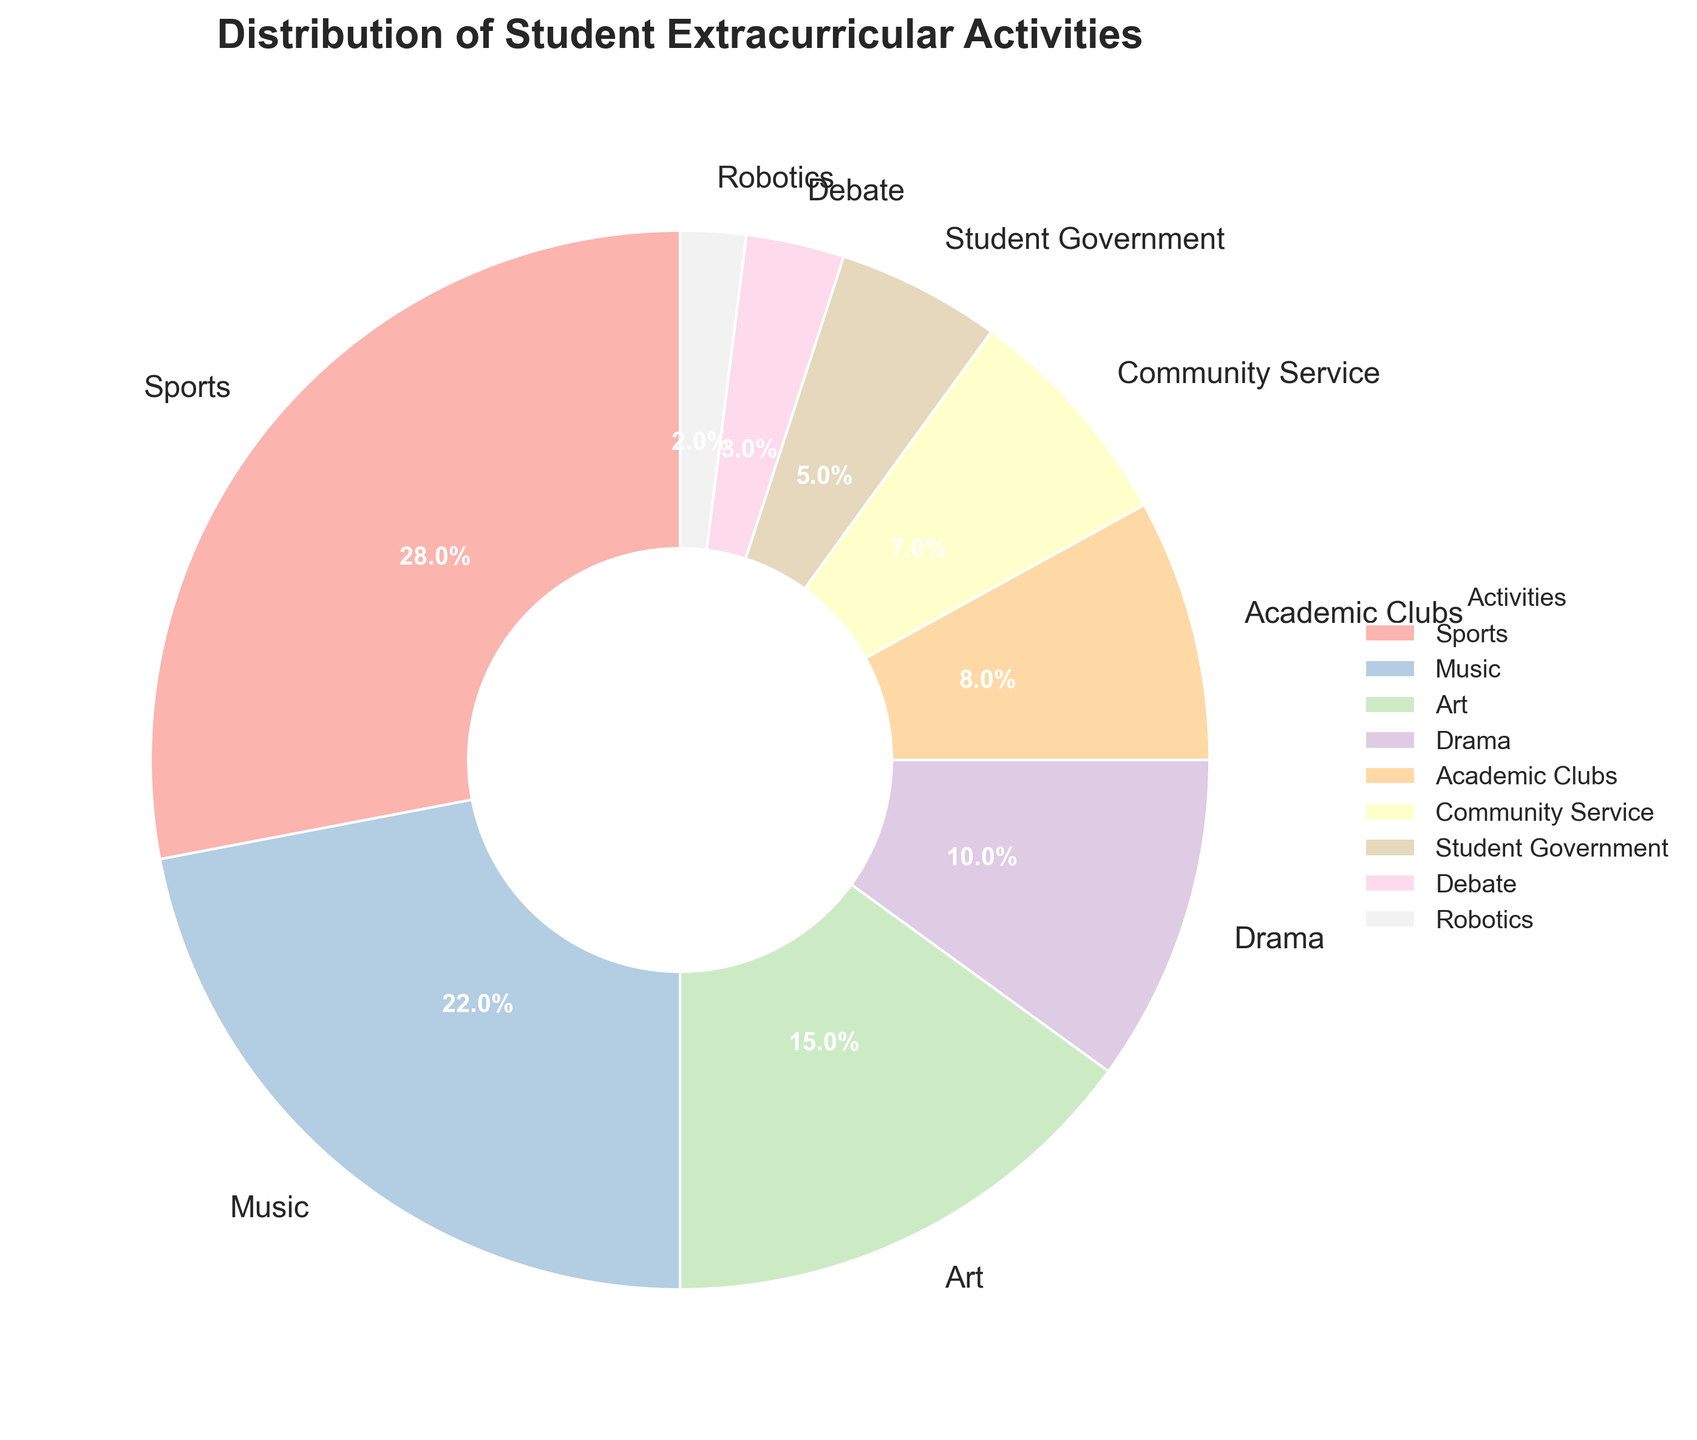What is the largest category in the pie chart? The largest category can be identified by the percentage allocation in the pie chart. The category with the highest percentage is Sports at 28%.
Answer: Sports What percentage of students participate in Music and Art combined? Sum the percentages of Music and Art: 22% (Music) + 15% (Art) = 37%.
Answer: 37% Which extracurricular activity has the lowest participation rate? The pie chart shows the activity with the smallest segment. Robotics has the lowest participation rate at 2%.
Answer: Robotics Are there more students participating in Drama than in Student Government? Compare the percentages for Drama (10%) and Student Government (5%). Drama has a higher percentage.
Answer: Yes By how much does participation in Sports exceed participation in Academic Clubs? Subtract the percentage of Academic Clubs from the percentage of Sports: 28% (Sports) - 8% (Academic Clubs) = 20%.
Answer: 20% What is the participation rate for Community Service, and how does it compare to Debate? The percentage for Community Service is 7%. Comparing it to Debate (3%), we see Community Service has a higher rate.
Answer: 7%, higher How many times bigger is the Music category compared to the Robotics category? Divide the percentage of Music by the percentage of Robotics: 22% (Music) / 2% (Robotics) = 11 times.
Answer: 11 times Which category has the third highest participation rate? Identify the first, second, and third largest segments. The third highest is Art at 15%.
Answer: Art How does the size of the Drama segment visually compare to the Student Government segment? The Drama segment is visually larger than the Student Government segment. Drama is at 10% while Student Government is at 5%.
Answer: Larger If you combine the participation rates of Student Government and Debate, what percentage do you get? Sum the percentages of Student Government and Debate: 5% + 3% = 8%.
Answer: 8% 